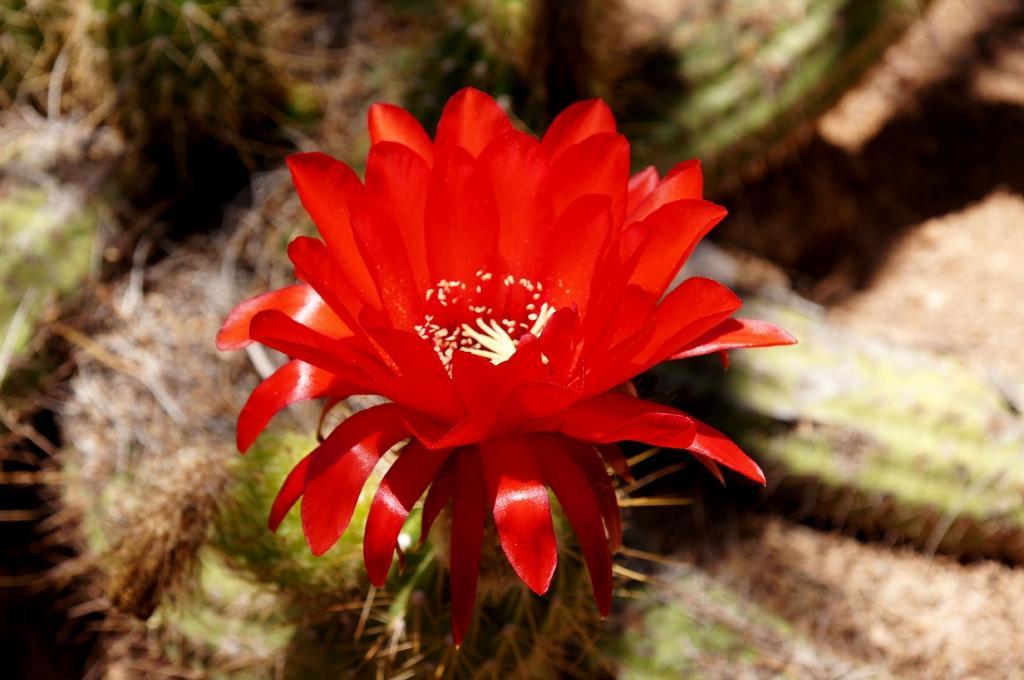In one or two sentences, can you explain what this image depicts? In this picture I can observe red color flower. The background is blurred. 